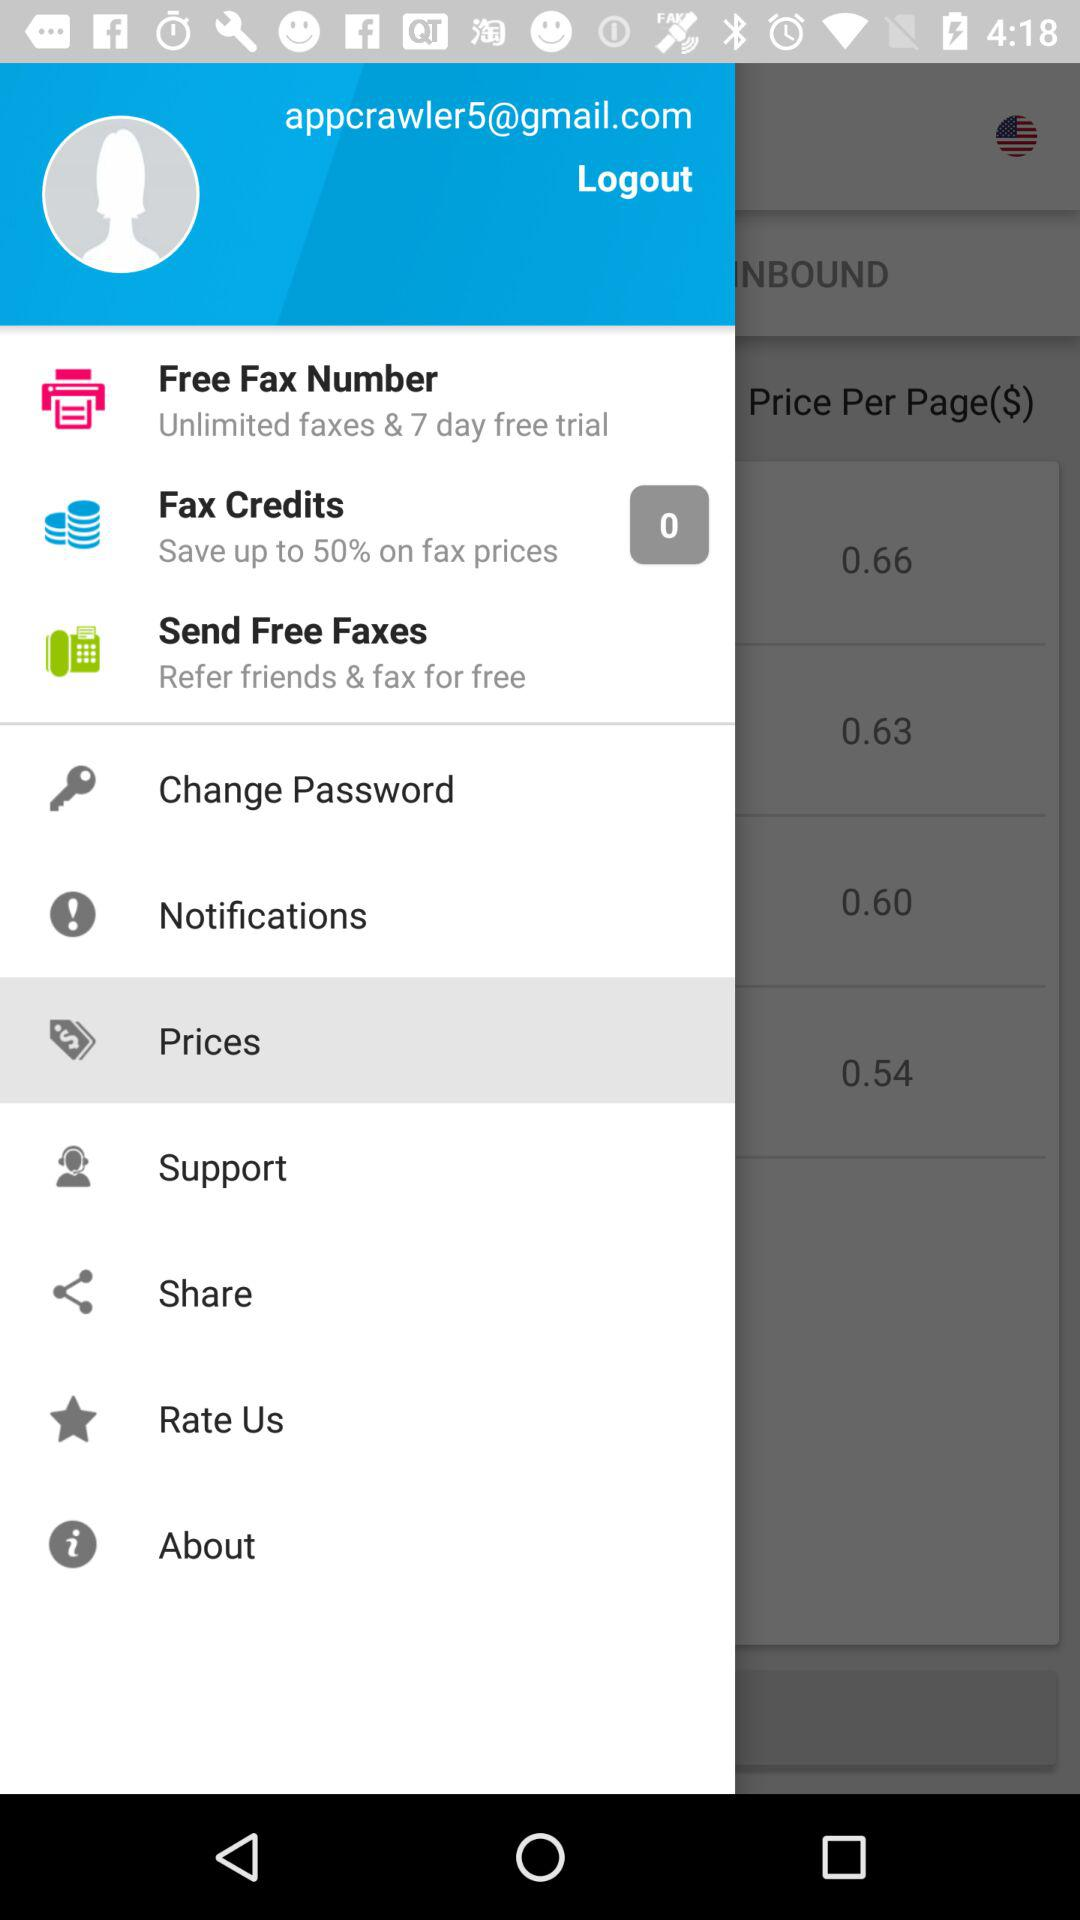Which is the selected item in the menu? The selected item is "Prices". 